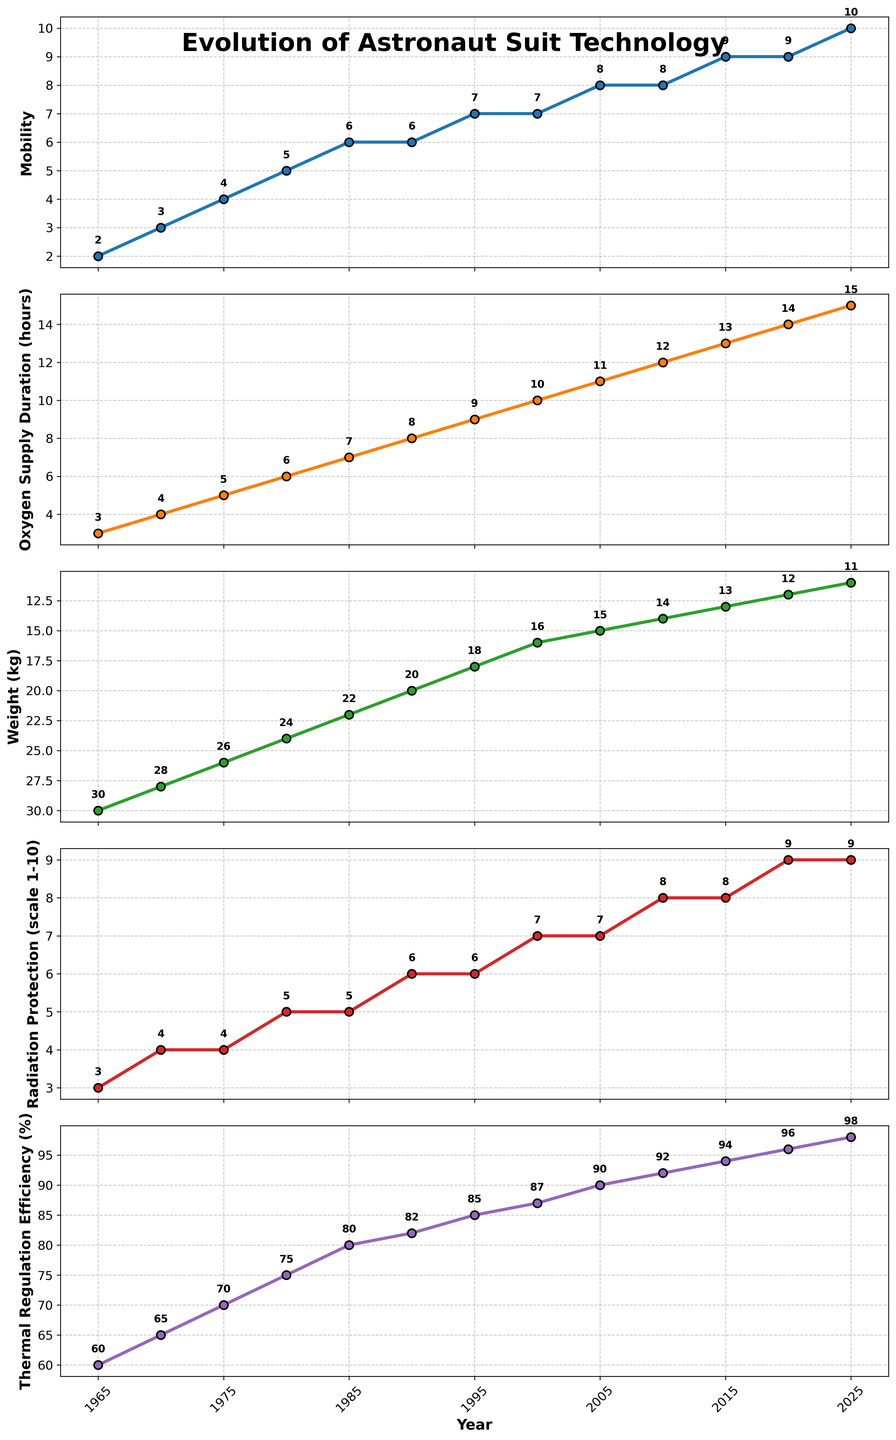What is the trend in the thermal regulation efficiency from 1965 to 2025? The thermal regulation efficiency shows a consistent increasing trend from 60% in 1965 to 98% in 2025. Each data point in the figure shows a higher value than the previous one.
Answer: Increasing trend Which metric shows a decreasing trend over the years? Among all the metrics displayed, the Weight (kg) is the only metric that shows a decreasing trend over time. The figure indicates the weight starts from 30 kg in 1965 and reduces to 11 kg in 2025.
Answer: Weight (kg) By how many units did the mobility increase from 1965 to 2025? According to the plot, the mobility in 1965 was 2, and in 2025, it's 10. The increase is 10 - 2 = 8 units.
Answer: 8 units Compare the oxygen supply duration and thermal regulation efficiency in 2010. Which one is higher? Referring to the plot, in 2010, the oxygen supply duration is 12 hours, while the thermal regulation efficiency is 92%. Since 92% is higher than 12 hours, the thermal regulation efficiency is higher.
Answer: Thermal regulation efficiency What year first introduced a mobility score of 7? The plot shows that mobility reached a score of 7 for the first time in 1995.
Answer: 1995 By how much has the radiation protection improved from 1980 to 2020? In 1980, the radiation protection scale was 5. By 2020, it had increased to 9. The improvement is 9 - 5 = 4 units.
Answer: 4 units Which metric saw no change between 1985 and 1990? The plot shows the same value for mobility in both 1985 and 1990, which is a score of 6. Therefore, mobility saw no change during this period.
Answer: Mobility What is the median value of the oxygen supply duration from 1965 to 2025? To find the median, list the oxygen supply duration values: 3, 4, 5, 6, 7, 8, 9, 10, 11, 12, 13, 14, 15. The median is the middle value, so 9 hours.
Answer: 9 hours Between which years did the weight of the astronaut suit decrease the most? Observing the plot, the most significant decrease in weight was between 1990 (20 kg) and 1995 (18 kg), a decrease of 2 kg.
Answer: 1990 and 1995 